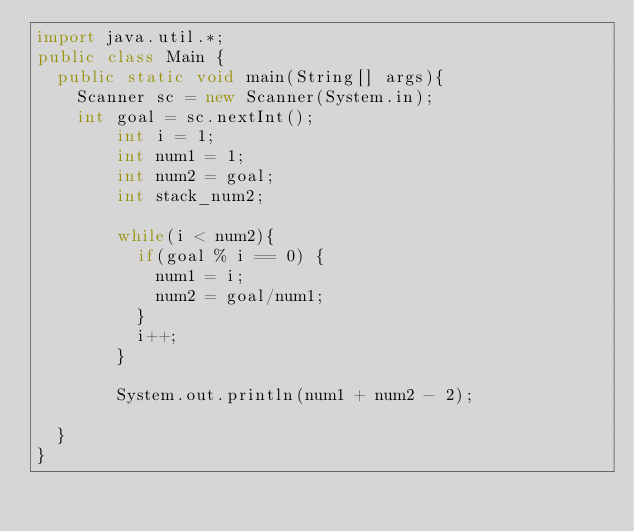<code> <loc_0><loc_0><loc_500><loc_500><_Java_>import java.util.*;
public class Main {
	public static void main(String[] args){
		Scanner sc = new Scanner(System.in);
		int goal = sc.nextInt();
      	int i = 1;
      	int num1 = 1;
      	int num2 = goal;
      	int stack_num2;
      
      	while(i < num2){
          if(goal % i == 0) {
            num1 = i;
            num2 = goal/num1;
          }
          i++;
        }
 		
      	System.out.println(num1 + num2 - 2);
        
	}
}
</code> 